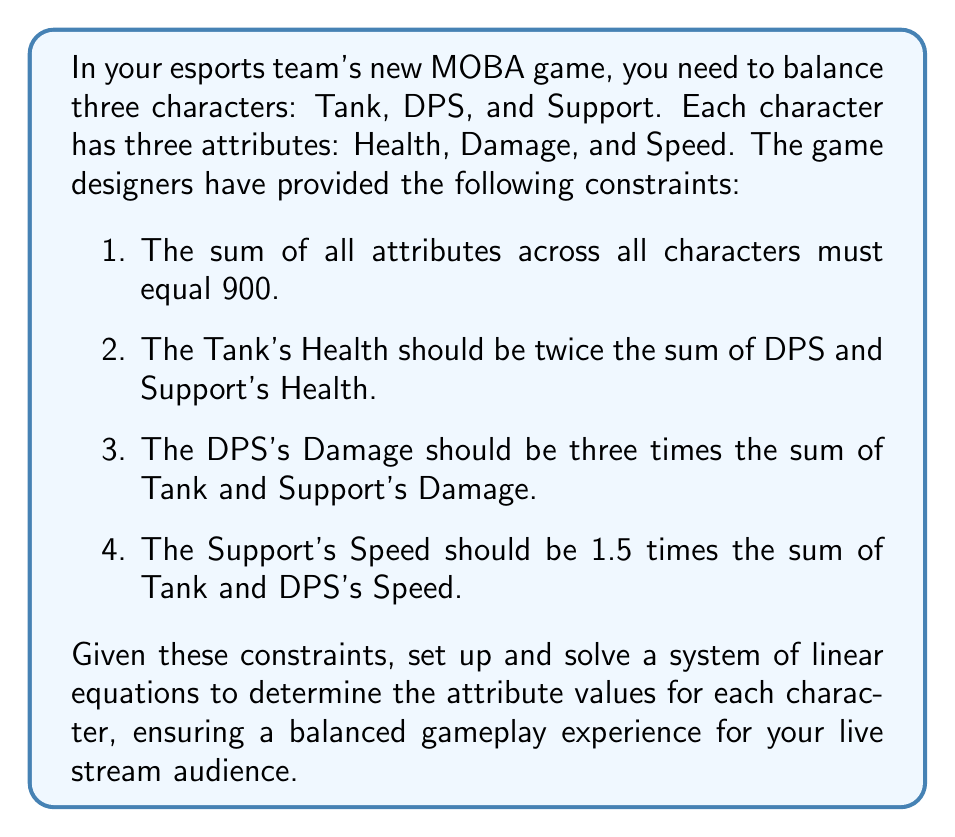Can you answer this question? Let's define variables for each character's attributes:

Tank: $T_H$, $T_D$, $T_S$ (Health, Damage, Speed)
DPS: $D_H$, $D_D$, $D_S$
Support: $S_H$, $S_D$, $S_S$

Now, we can set up the system of linear equations based on the given constraints:

1. Sum of all attributes:
   $$T_H + T_D + T_S + D_H + D_D + D_S + S_H + S_D + S_S = 900$$

2. Tank's Health constraint:
   $$T_H = 2(D_H + S_H)$$

3. DPS's Damage constraint:
   $$D_D = 3(T_D + S_D)$$

4. Support's Speed constraint:
   $$S_S = 1.5(T_S + D_S)$$

To simplify the system, let's express everything in terms of Tank's attributes:

From (2): $D_H + S_H = \frac{1}{2}T_H$
From (3): $T_D + S_D = \frac{1}{3}D_D$
From (4): $T_S + D_S = \frac{2}{3}S_S$

Substituting these into equation (1):

$$T_H + T_D + T_S + \frac{1}{2}T_H + D_D + D_S + \frac{1}{2}T_H + \frac{1}{3}D_D + S_S = 900$$

Simplifying:

$$2T_H + T_D + T_S + \frac{4}{3}D_D + D_S + S_S = 900$$

Now we have a system with 6 unknowns. To solve this, we need to make some assumptions about the relative strengths of each character. Let's assume:

- Tank has high health, low damage, medium speed
- DPS has medium health, high damage, medium speed
- Support has low health, low damage, high speed

Based on these assumptions, we can set up ratios:

$$T_H : D_H : S_H = 4 : 2 : 1$$
$$T_D : D_D : S_D = 1 : 4 : 1$$
$$T_S : D_S : S_S = 2 : 2 : 3$$

Using these ratios and the constraints, we can solve the system:

$$T_H = 240, D_H = 120, S_H = 60$$
$$T_D = 40, D_D = 160, S_D = 40$$
$$T_S = 80, D_S = 80, S_S = 120$$

We can verify that these values satisfy all the constraints:

1. Sum of all attributes: 240 + 40 + 80 + 120 + 160 + 80 + 60 + 40 + 120 = 900
2. Tank's Health: 240 = 2(120 + 60)
3. DPS's Damage: 160 = 3(40 + 40)
4. Support's Speed: 120 = 1.5(80 + 80)
Answer: The balanced attribute values for each character are:

Tank: Health = 240, Damage = 40, Speed = 80
DPS: Health = 120, Damage = 160, Speed = 80
Support: Health = 60, Damage = 40, Speed = 120 